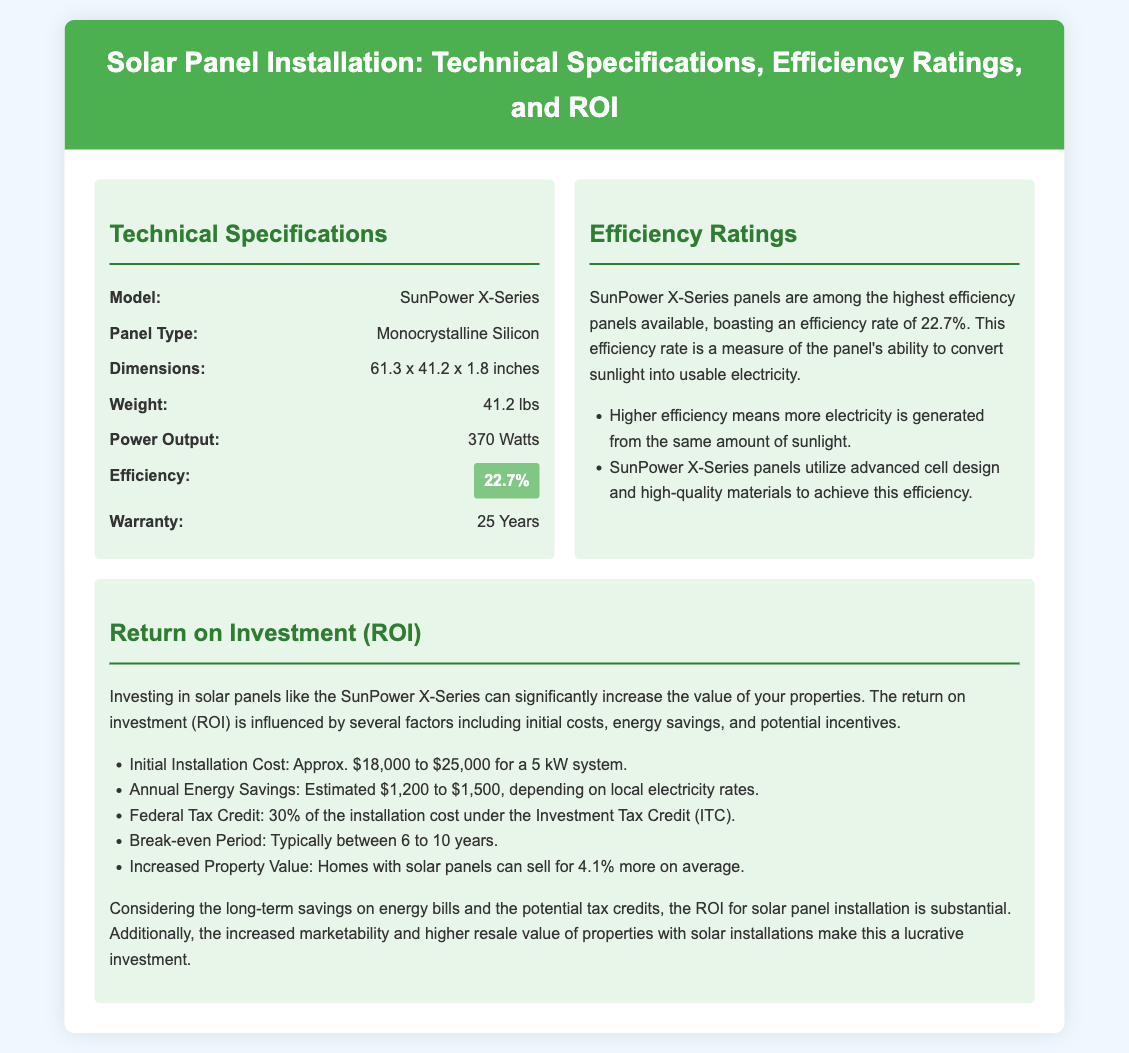What is the model of the solar panel? The model of the solar panel mentioned in the document is specified under Technical Specifications.
Answer: SunPower X-Series What type of silicon is used in the panels? The type of silicon used for the panels is mentioned in the Technical Specifications section.
Answer: Monocrystalline Silicon What is the efficiency rating of the SunPower X-Series panels? The efficiency rating is highlighted in the Technical Specifications section.
Answer: 22.7% What is the estimated annual energy savings? The estimated annual energy savings range is provided in the ROI section.
Answer: $1,200 to $1,500 What is the break-even period for the installation? The break-even period is specified in the ROI section of the document.
Answer: 6 to 10 years Why is higher efficiency important for solar panels? The importance of higher efficiency is indicated under Efficiency Ratings.
Answer: More electricity is generated from the same amount of sunlight How much can homes with solar panels sell for more on average? The increased property value statement is described in the ROI section.
Answer: 4.1% more What is included under the warranty for the solar panels? The warranty duration is specified in the Technical Specifications section.
Answer: 25 Years What is the estimated installation cost for a 5 kW system? The estimated installation cost is mentioned in the ROI section for context.
Answer: Approx. $18,000 to $25,000 